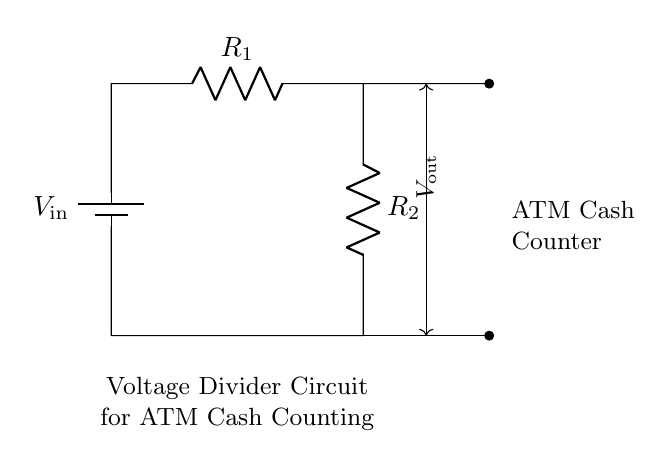What is the input voltage of this circuit? The circuit is powered by a voltage source labeled as V_in, which represents the input voltage. The specific value is not provided in the diagram, but it is indicated as a fundamental parameter in the voltage divider setup.
Answer: V_in What are the two resistors in this circuit called? The circuit contains two resistors labeled R_1 and R_2. They are essential components of the voltage divider, dividing the input voltage between them.
Answer: R_1 and R_2 What is the purpose of this circuit? This circuit is designed as a voltage divider specifically for ATM cash counting. It ensures that the output voltage is proportional to the input voltage, providing a precise measurement for cash counting purposes.
Answer: ATM Cash Counting What is the output voltage denoted as? The output voltage from this voltage divider circuit is represented by V_out, indicating the voltage that is taken across the resistors. This is crucial for the application in cash counting.
Answer: V_out If R_1 is 10k ohms and R_2 is 5k ohms, what is the ratio of R_1 to R_2? The ratio of R_1 to R_2 can be calculated by dividing the resistance values: R_1 divided by R_2 equals 10k ohms divided by 5k ohms, which simplifies to 2. This ratio indicates how the resistances affect the output voltage.
Answer: 2 How does this voltage divider affect the output voltage? The voltage divider affects the output voltage by dividing the input voltage into smaller parts, proportional to the resistance values of R_1 and R_2. The formula for V_out is V_out equals V_in multiplied by the ratio R_2 divided by the sum of R_1 and R_2. This defines how the voltage is split.
Answer: Divides the input voltage What does the arrow on the output voltage indicate? The arrow on the output voltage, labeled as V_out, indicates the direction of the measured voltage that is taken from the circuit between R_1 and R_2. It signifies where the output is obtained for measuring purposes.
Answer: Measurement direction 